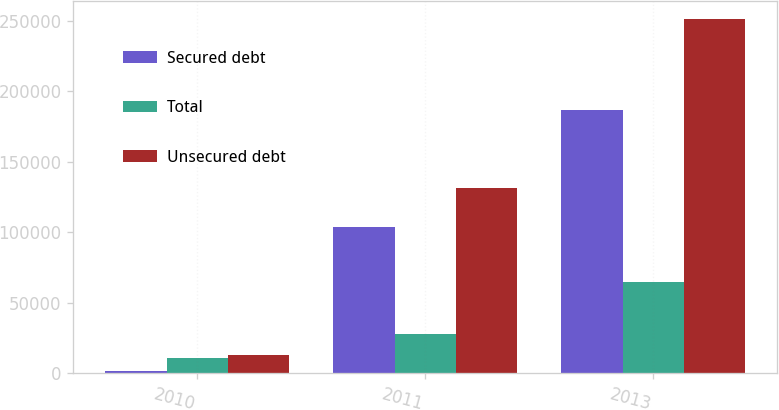<chart> <loc_0><loc_0><loc_500><loc_500><stacked_bar_chart><ecel><fcel>2010<fcel>2011<fcel>2013<nl><fcel>Secured debt<fcel>1673<fcel>103533<fcel>186460<nl><fcel>Total<fcel>11037<fcel>27819<fcel>64961<nl><fcel>Unsecured debt<fcel>12710<fcel>131352<fcel>251421<nl></chart> 